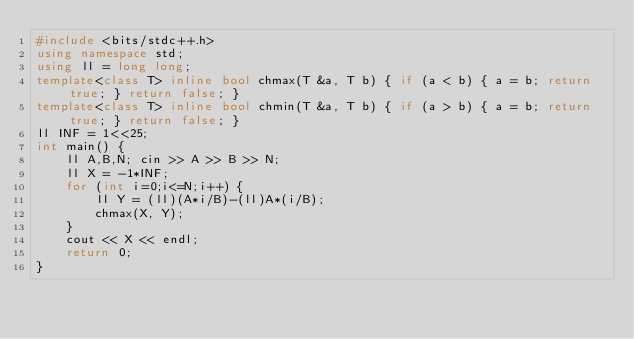Convert code to text. <code><loc_0><loc_0><loc_500><loc_500><_C++_>#include <bits/stdc++.h>
using namespace std;
using ll = long long;
template<class T> inline bool chmax(T &a, T b) { if (a < b) { a = b; return true; } return false; }
template<class T> inline bool chmin(T &a, T b) { if (a > b) { a = b; return true; } return false; }
ll INF = 1<<25;
int main() {
    ll A,B,N; cin >> A >> B >> N;
    ll X = -1*INF;
    for (int i=0;i<=N;i++) {
        ll Y = (ll)(A*i/B)-(ll)A*(i/B);
        chmax(X, Y);
    }
    cout << X << endl;
    return 0;
}</code> 